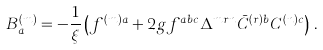<formula> <loc_0><loc_0><loc_500><loc_500>B ^ { ( m ) } _ { a } = - \frac { 1 } { \xi } \left ( f ^ { ( m ) a } + 2 g f ^ { a b c } \Delta ^ { m r n } \bar { C } ^ { ( r ) b } C ^ { ( n ) c } \right ) \, .</formula> 